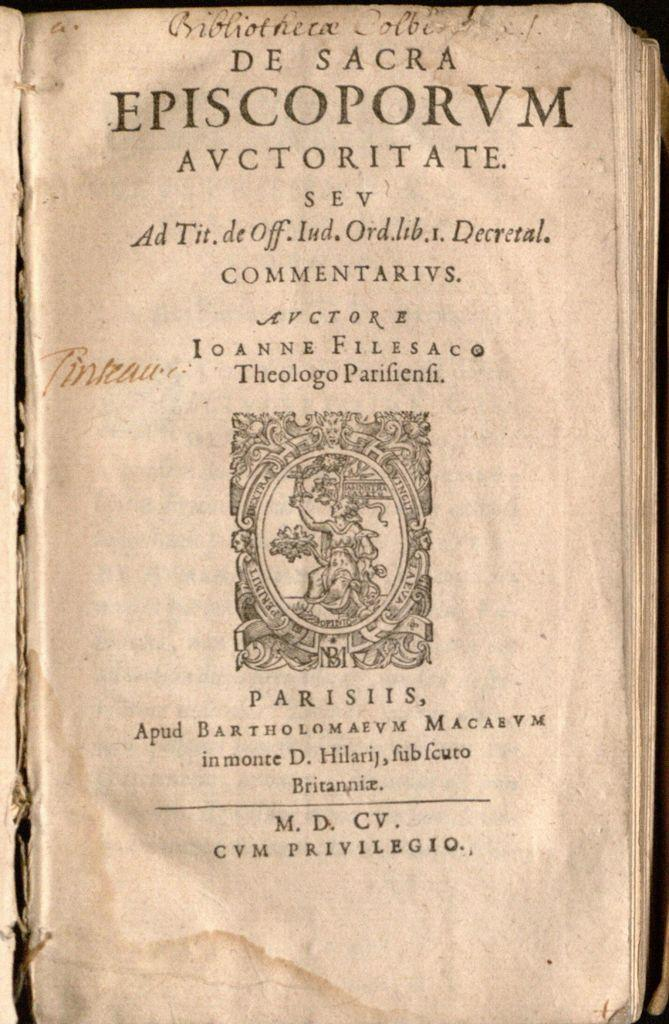<image>
Create a compact narrative representing the image presented. a page with the words 'de sacra episcoporvm avctoritate.' at the top 